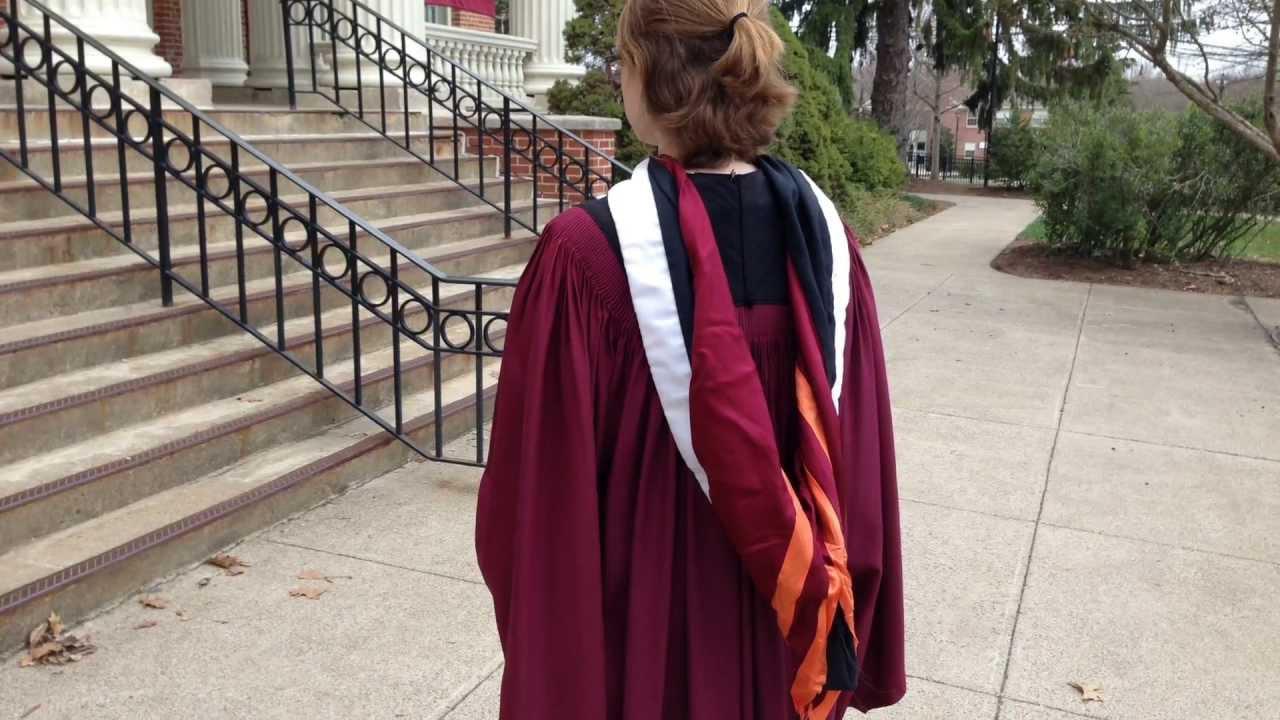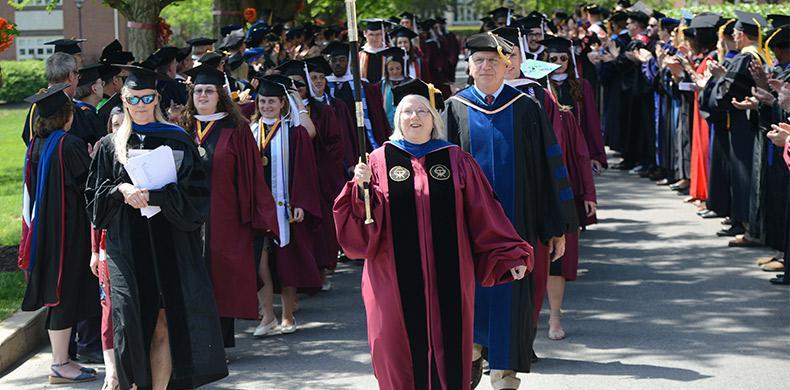The first image is the image on the left, the second image is the image on the right. For the images displayed, is the sentence "The graduate in the left image can be seen smiling." factually correct? Answer yes or no. No. The first image is the image on the left, the second image is the image on the right. For the images displayed, is the sentence "In one of the images, there is only one person, and they are facing away from the camera." factually correct? Answer yes or no. Yes. 